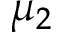Convert formula to latex. <formula><loc_0><loc_0><loc_500><loc_500>\mu _ { 2 }</formula> 